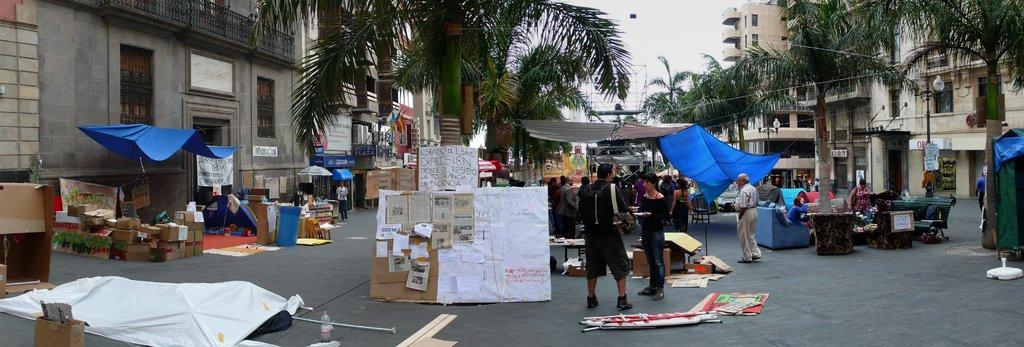What type of people can be seen in the image? There are street vendors in the image. What materials are used by the street vendors? Polythene sheets and cardboard cartons are present in the image. How are the cardboard cartons being used? Papers are attached to the cardboard in the image. What type of natural elements can be seen in the image? Trees are present in the image. What type of man-made structures can be seen in the image? Buildings are visible in the image. What type of architectural feature is present in the image? Railings are present in the image. What are the persons in the image doing? There are persons standing on the road in the image. What is visible in the sky in the image? The sky is visible in the image. What type of fiction is being sold by the street vendors in the image? There is no indication of any fiction being sold in the image; the street vendors are using polythene sheets and cardboard cartons for other purposes. What type of bait is being used by the persons standing on the road in the image? There is no bait present in the image; the persons standing on the road are not engaged in any activity related to bait. 